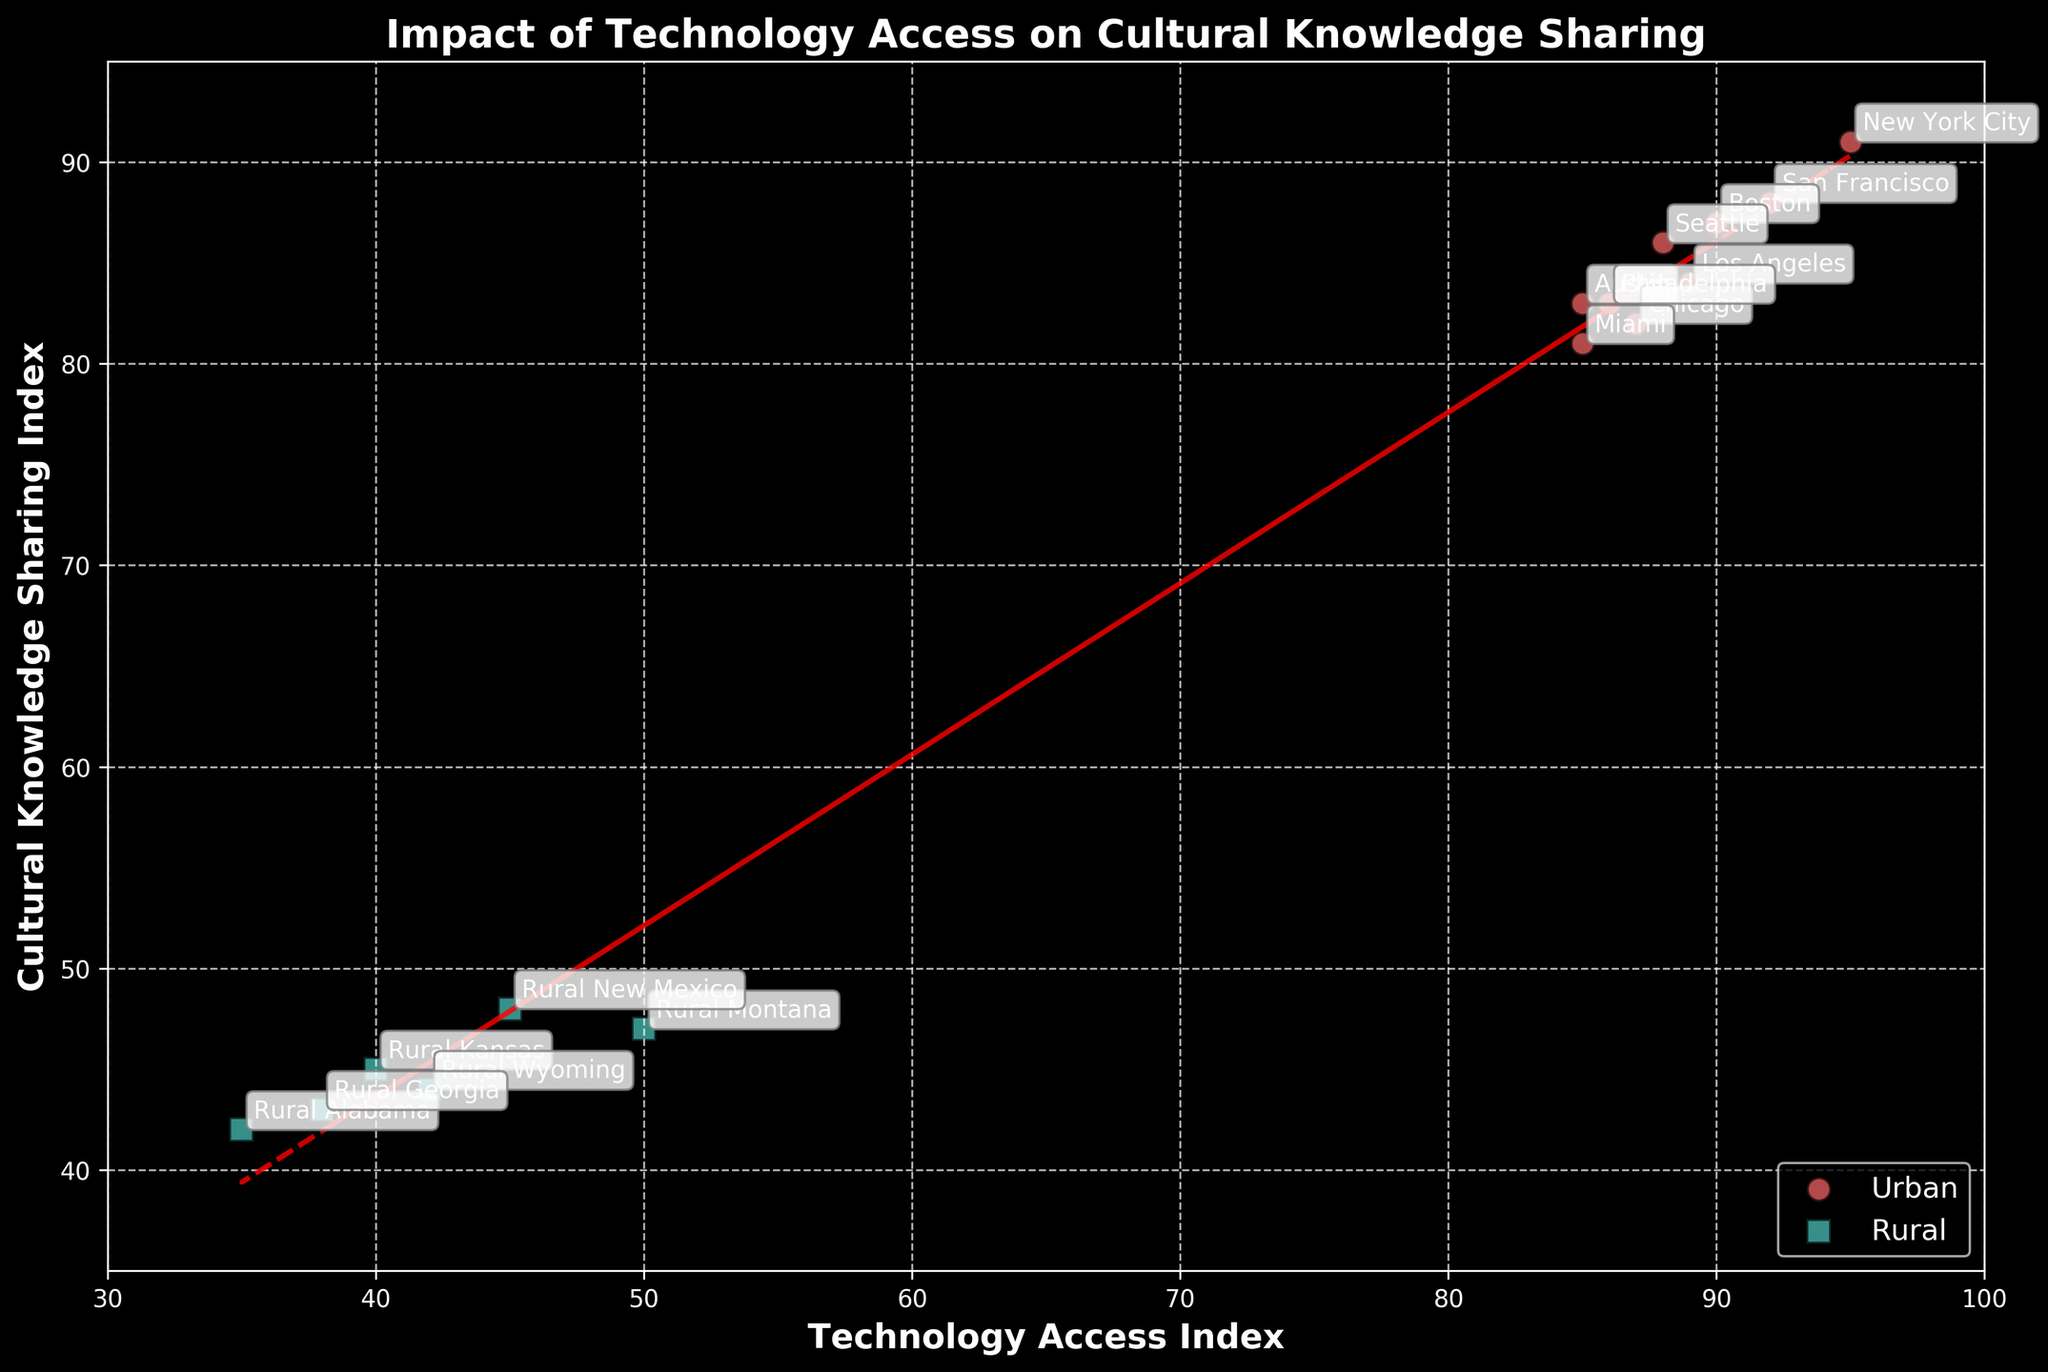Which region has the highest Technology Access Index? By inspecting the scatter plot, we can identify that New York City has the highest Technology Access Index, shown by the highest point on the x-axis.
Answer: New York City Are urban areas generally better at cultural knowledge sharing compared to rural areas? By observing the scatter plot, urban regions (circular markers) are mostly clustered in the higher Cultural Knowledge Sharing Index range compared to rural regions (square markers).
Answer: Yes What is the overall trend between Technology Access Index and Cultural Knowledge Sharing Index? The plotted trend line slope indicates a positive relationship, meaning higher Technology Access Index values are associated with higher Cultural Knowledge Sharing Index values.
Answer: Positive trend Is there any rural area with a Technology Access Index above 50? By examining the plot, none of the rural areas (square markers) are positioned to the right of the 50 value on the x-axis.
Answer: No How does the Cultural Knowledge Sharing Index of Chicago compare to that of Miami? The scatter plot shows that Chicago has a slightly higher Cultural Knowledge Sharing Index (~82) compared to Miami (~81).
Answer: Chicago is higher Which urban region has the lowest Cultural Knowledge Sharing Index? By noticing towards the lower end of the Cultural Knowledge Sharing Index axis, Los Angeles stands out as the urban region with the lowest value (~84).
Answer: Los Angeles Does the region with the highest Cultural Knowledge Sharing Index also have the highest Technology Access Index? New York City appears to have both the highest Cultural Knowledge Sharing Index and the highest Technology Access Index, which aligns with the top-right point of the plot.
Answer: Yes Calculate the approximate average Technology Access Index for rural regions. The Technology Access Indices for rural regions are 40, 35, 50, 42, 38, and 45. Summing these values gives 250, and there are six data points. Dividing 250 by 6 results in approximately 41.67.
Answer: ~41.67 Which urban region has a Technology Access Index closest to 90? Inspecting the plot, Boston is noted closest to the 90 mark on the x-axis for urban regions.
Answer: Boston 